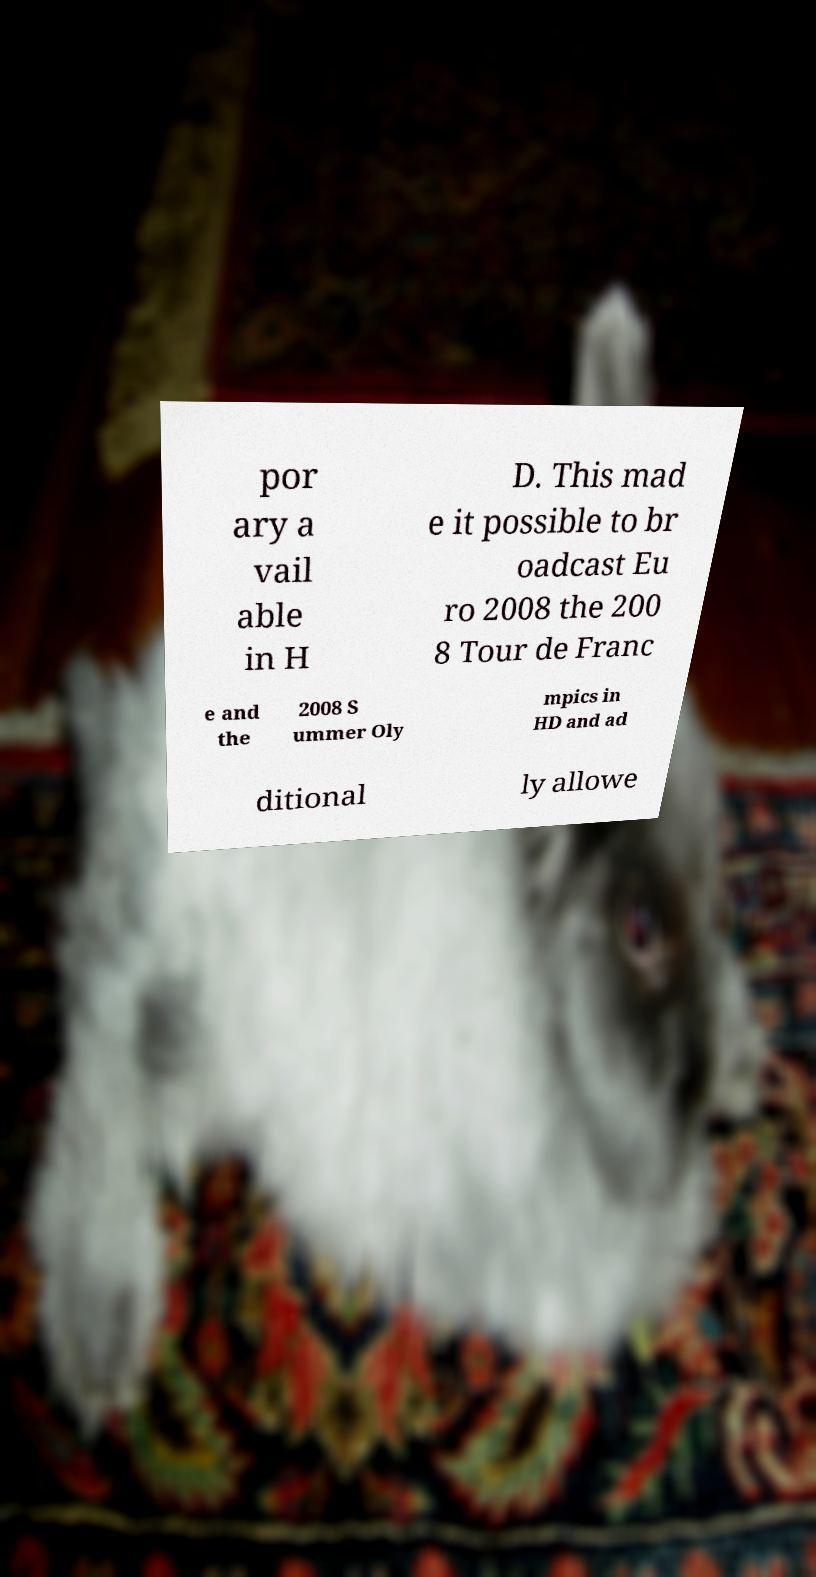Can you accurately transcribe the text from the provided image for me? por ary a vail able in H D. This mad e it possible to br oadcast Eu ro 2008 the 200 8 Tour de Franc e and the 2008 S ummer Oly mpics in HD and ad ditional ly allowe 